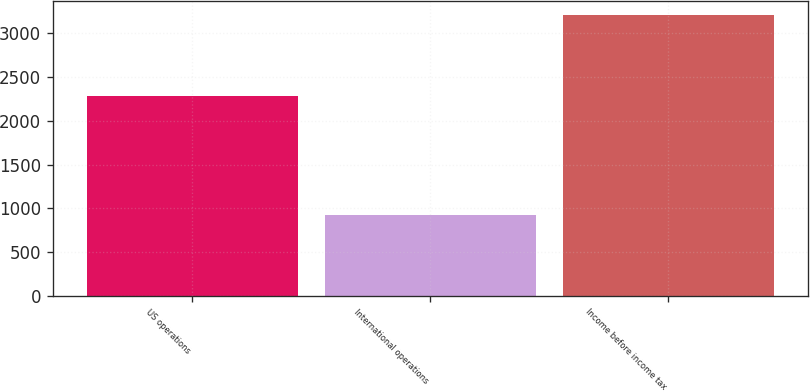<chart> <loc_0><loc_0><loc_500><loc_500><bar_chart><fcel>US operations<fcel>International operations<fcel>Income before income tax<nl><fcel>2283<fcel>924<fcel>3207<nl></chart> 